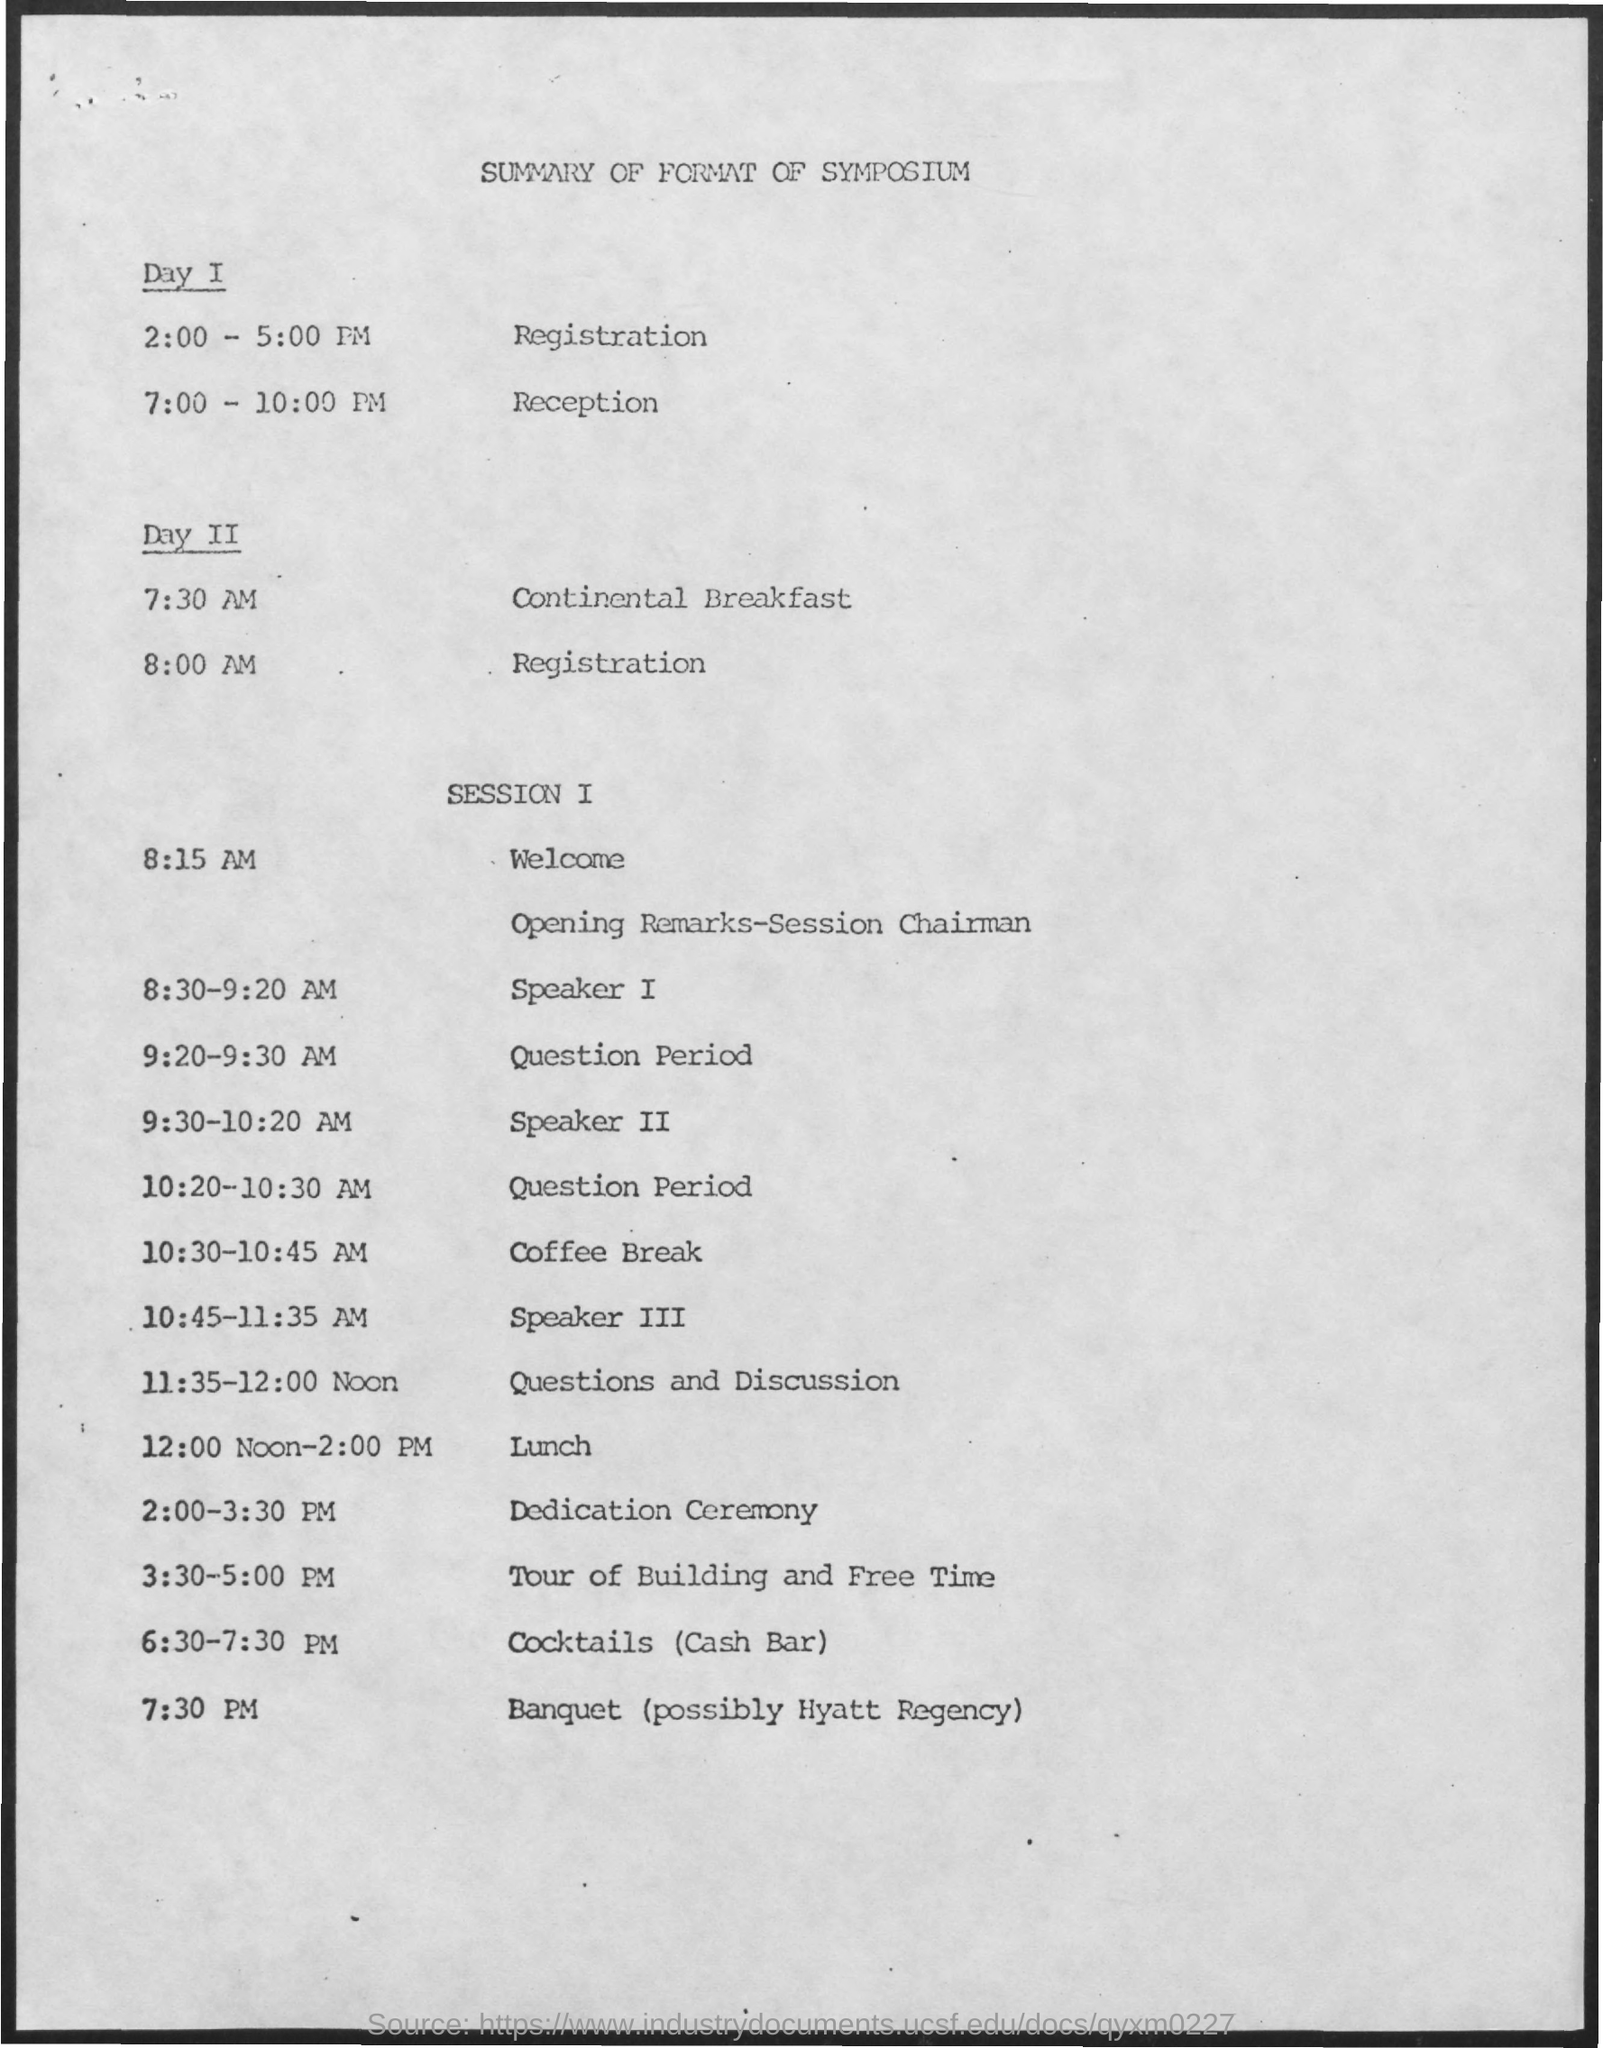What is the schedule at the time of 2:00 - 5:00 pm on day 1?
Provide a succinct answer. Registration. What is the schedule at the time of 7:00-10:00 pm on day 1?
Ensure brevity in your answer.  Reception. What is the schedule at the time of 7:30 am on day 2?
Ensure brevity in your answer.  Continental breakfast. What is the schedule at the time of 8:00 am on day 2?
Your response must be concise. Registration. What is the schedule at the time of 12:00 noon- 2:00 pm in session 1?
Make the answer very short. Lunch. 